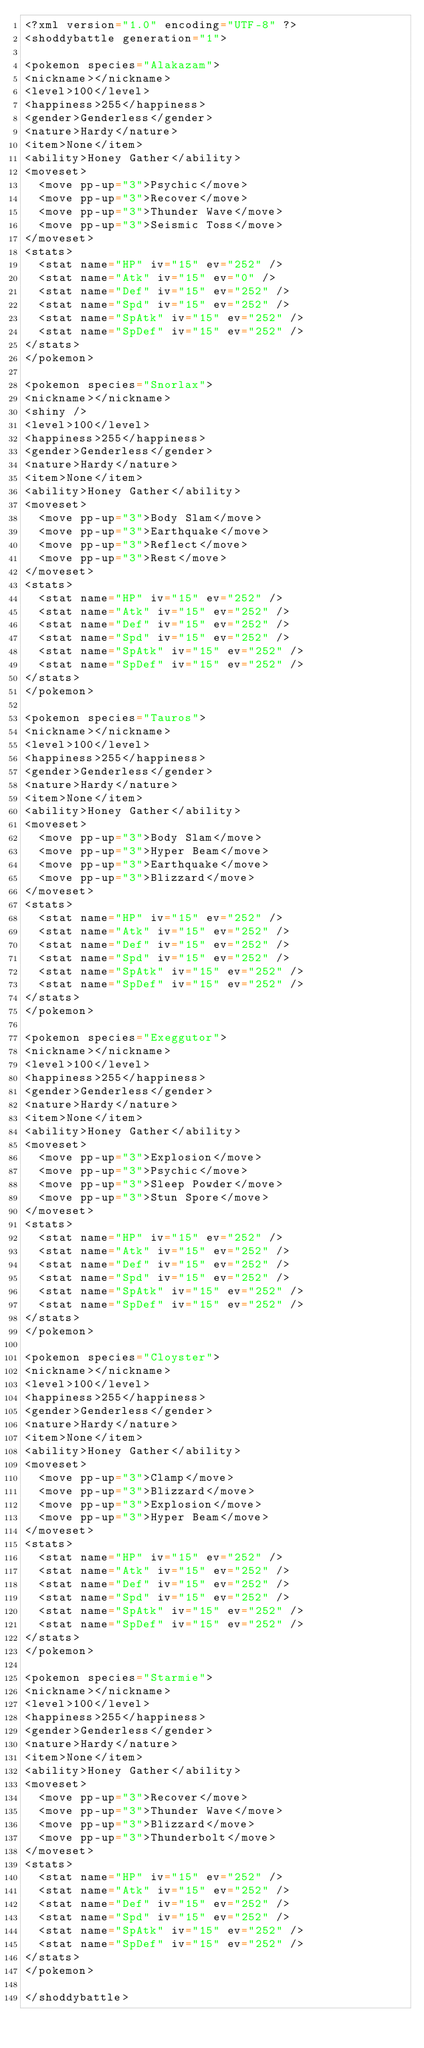<code> <loc_0><loc_0><loc_500><loc_500><_Scala_><?xml version="1.0" encoding="UTF-8" ?>
<shoddybattle generation="1">

<pokemon species="Alakazam">
<nickname></nickname>
<level>100</level>
<happiness>255</happiness>
<gender>Genderless</gender>
<nature>Hardy</nature>
<item>None</item>
<ability>Honey Gather</ability>
<moveset>
	<move pp-up="3">Psychic</move>
	<move pp-up="3">Recover</move>
	<move pp-up="3">Thunder Wave</move>
	<move pp-up="3">Seismic Toss</move>
</moveset>
<stats>
	<stat name="HP" iv="15" ev="252" />
	<stat name="Atk" iv="15" ev="0" />
	<stat name="Def" iv="15" ev="252" />
	<stat name="Spd" iv="15" ev="252" />
	<stat name="SpAtk" iv="15" ev="252" />
	<stat name="SpDef" iv="15" ev="252" />
</stats>
</pokemon>

<pokemon species="Snorlax">
<nickname></nickname>
<shiny />
<level>100</level>
<happiness>255</happiness>
<gender>Genderless</gender>
<nature>Hardy</nature>
<item>None</item>
<ability>Honey Gather</ability>
<moveset>
	<move pp-up="3">Body Slam</move>
	<move pp-up="3">Earthquake</move>
	<move pp-up="3">Reflect</move>
	<move pp-up="3">Rest</move>
</moveset>
<stats>
	<stat name="HP" iv="15" ev="252" />
	<stat name="Atk" iv="15" ev="252" />
	<stat name="Def" iv="15" ev="252" />
	<stat name="Spd" iv="15" ev="252" />
	<stat name="SpAtk" iv="15" ev="252" />
	<stat name="SpDef" iv="15" ev="252" />
</stats>
</pokemon>

<pokemon species="Tauros">
<nickname></nickname>
<level>100</level>
<happiness>255</happiness>
<gender>Genderless</gender>
<nature>Hardy</nature>
<item>None</item>
<ability>Honey Gather</ability>
<moveset>
	<move pp-up="3">Body Slam</move>
	<move pp-up="3">Hyper Beam</move>
	<move pp-up="3">Earthquake</move>
	<move pp-up="3">Blizzard</move>
</moveset>
<stats>
	<stat name="HP" iv="15" ev="252" />
	<stat name="Atk" iv="15" ev="252" />
	<stat name="Def" iv="15" ev="252" />
	<stat name="Spd" iv="15" ev="252" />
	<stat name="SpAtk" iv="15" ev="252" />
	<stat name="SpDef" iv="15" ev="252" />
</stats>
</pokemon>

<pokemon species="Exeggutor">
<nickname></nickname>
<level>100</level>
<happiness>255</happiness>
<gender>Genderless</gender>
<nature>Hardy</nature>
<item>None</item>
<ability>Honey Gather</ability>
<moveset>
	<move pp-up="3">Explosion</move>
	<move pp-up="3">Psychic</move>
	<move pp-up="3">Sleep Powder</move>
	<move pp-up="3">Stun Spore</move>
</moveset>
<stats>
	<stat name="HP" iv="15" ev="252" />
	<stat name="Atk" iv="15" ev="252" />
	<stat name="Def" iv="15" ev="252" />
	<stat name="Spd" iv="15" ev="252" />
	<stat name="SpAtk" iv="15" ev="252" />
	<stat name="SpDef" iv="15" ev="252" />
</stats>
</pokemon>

<pokemon species="Cloyster">
<nickname></nickname>
<level>100</level>
<happiness>255</happiness>
<gender>Genderless</gender>
<nature>Hardy</nature>
<item>None</item>
<ability>Honey Gather</ability>
<moveset>
	<move pp-up="3">Clamp</move>
	<move pp-up="3">Blizzard</move>
	<move pp-up="3">Explosion</move>
	<move pp-up="3">Hyper Beam</move>
</moveset>
<stats>
	<stat name="HP" iv="15" ev="252" />
	<stat name="Atk" iv="15" ev="252" />
	<stat name="Def" iv="15" ev="252" />
	<stat name="Spd" iv="15" ev="252" />
	<stat name="SpAtk" iv="15" ev="252" />
	<stat name="SpDef" iv="15" ev="252" />
</stats>
</pokemon>

<pokemon species="Starmie">
<nickname></nickname>
<level>100</level>
<happiness>255</happiness>
<gender>Genderless</gender>
<nature>Hardy</nature>
<item>None</item>
<ability>Honey Gather</ability>
<moveset>
	<move pp-up="3">Recover</move>
	<move pp-up="3">Thunder Wave</move>
	<move pp-up="3">Blizzard</move>
	<move pp-up="3">Thunderbolt</move>
</moveset>
<stats>
	<stat name="HP" iv="15" ev="252" />
	<stat name="Atk" iv="15" ev="252" />
	<stat name="Def" iv="15" ev="252" />
	<stat name="Spd" iv="15" ev="252" />
	<stat name="SpAtk" iv="15" ev="252" />
	<stat name="SpDef" iv="15" ev="252" />
</stats>
</pokemon>

</shoddybattle>
</code> 